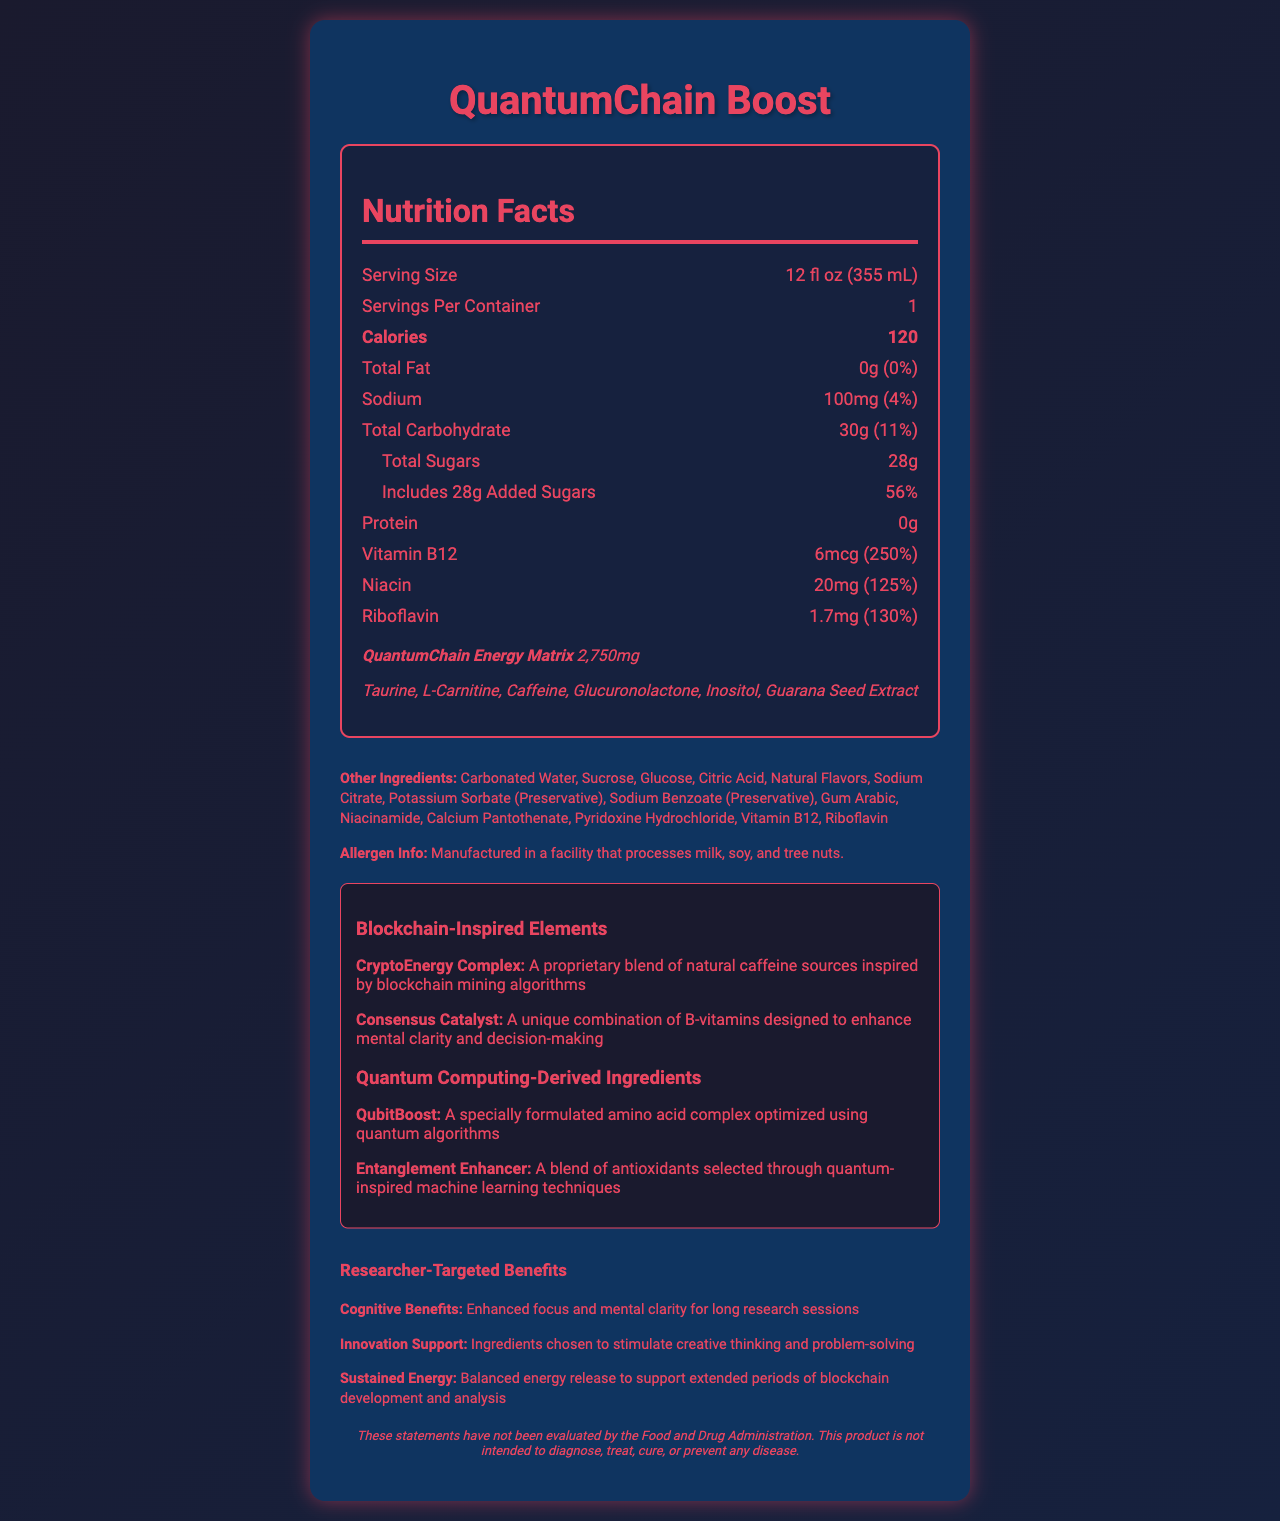what is the serving size of QuantumChain Boost? The serving size is listed at the top of the nutrition facts section of the document.
Answer: 12 fl oz (355 mL) how many calories are in one serving of QuantumChain Boost? The calorie count is shown prominently in the nutrition facts section in bold.
Answer: 120 what is the total fat content in one serving? The total fat content is listed as "0g" with a 0% daily value.
Answer: 0g how much sodium is present in QuantumChain Boost? The sodium content is displayed in the nutrition facts section as 100mg, constituting 4% of the daily value.
Answer: 100mg how many grams of added sugars are in QuantumChain Boost? The amount of added sugars is provided in the nutrition facts section as 28g, which is 56% of the daily value.
Answer: 28g which ingredient is part of the "QuantumChain Energy Matrix" proprietary blend? A. Guarana Seed Extract B. Sodium Benzoate C. Vitamin B12 D. Gum Arabic Guarana Seed Extract is listed among the ingredients in the "QuantumChain Energy Matrix" proprietary blend.
Answer: A what percentage of the daily value for Vitamin B12 is provided by QuantumChain Boost? A. 100% B. 200% C. 250% D. 150% The document lists the daily value for Vitamin B12 as 250%.
Answer: C is QuantumChain Boost a good source of protein? The nutrition facts indicate that QuantumChain Boost contains 0g of protein.
Answer: No is there any allergen information provided for QuantumChain Boost? The document specifies that it is manufactured in a facility that processes milk, soy, and tree nuts.
Answer: Yes describe the main features and purpose of the QuantumChain Boost Nutrition Facts document. The document is structured to provide comprehensive nutrition information, featuring various unique ingredients and benefits targeted at researchers, along with traditional nutritional details, proprietary blends, and special elements inspired by blockchain and quantum computing technologies.
Answer: The QuantumChain Boost Nutrition Facts document provides detailed nutritional information for the product, including serving size, calorie count, and content of various nutrients like fats, carbohydrates, sugars, protein, and certain vitamins and minerals. It also highlights a proprietary blend called the "QuantumChain Energy Matrix," lists other ingredients, and includes blockchain-inspired elements and quantum computing-derived ingredients. Additionally, the document contains a section targeted at researchers, noting cognitive benefits, innovation support, and sustained energy. There is also a disclaimer about the product's health claims. what is the maximum amount of carbohydrate present in QuantumChain Boost? The total carbohydrate content is provided for one serving (30g), but the document does not specify the maximum carbohydrate content for multiple servings.
Answer: Cannot be determined what is the innovation support benefit mentioned for researchers? The researcher-targeted information section mentions that the ingredients are chosen to support creative thinking and problem-solving.
Answer: Ingredients chosen to stimulate creative thinking and problem-solving what is the daily value percentage for Riboflavin provided by QuantumChain Boost? The document indicates that one serving provides 130% of the daily value for Riboflavin.
Answer: 130% how is the Cognitive Benefits section specifically tailored for researchers? A. Tailored workout plans B. Enhanced focus and mental clarity C. Physical endurance training D. Complex carbohydrate recipes The cognitive benefits section mentions "Enhanced focus and mental clarity for long research sessions," which is specifically tailored for researchers.
Answer: B 